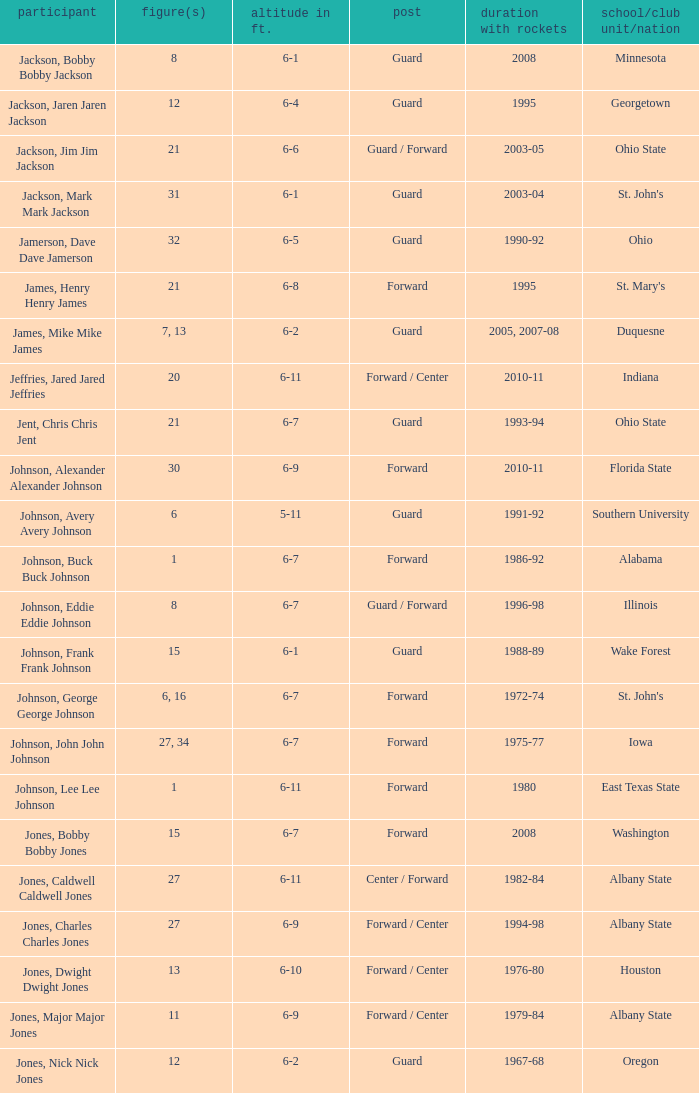What is the number of the player who went to Southern University? 6.0. 